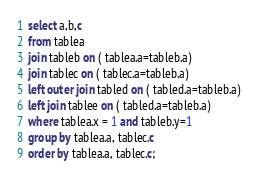<code> <loc_0><loc_0><loc_500><loc_500><_SQL_>select a,b,c
from tablea
join tableb on ( tablea.a=tableb.a)
join tablec on ( tablec.a=tableb.a)
left outer join tabled on ( tabled.a=tableb.a)
left join tablee on ( tabled.a=tableb.a)
where tablea.x = 1 and tableb.y=1
group by tablea.a, tablec.c
order by tablea.a, tablec.c;


</code> 